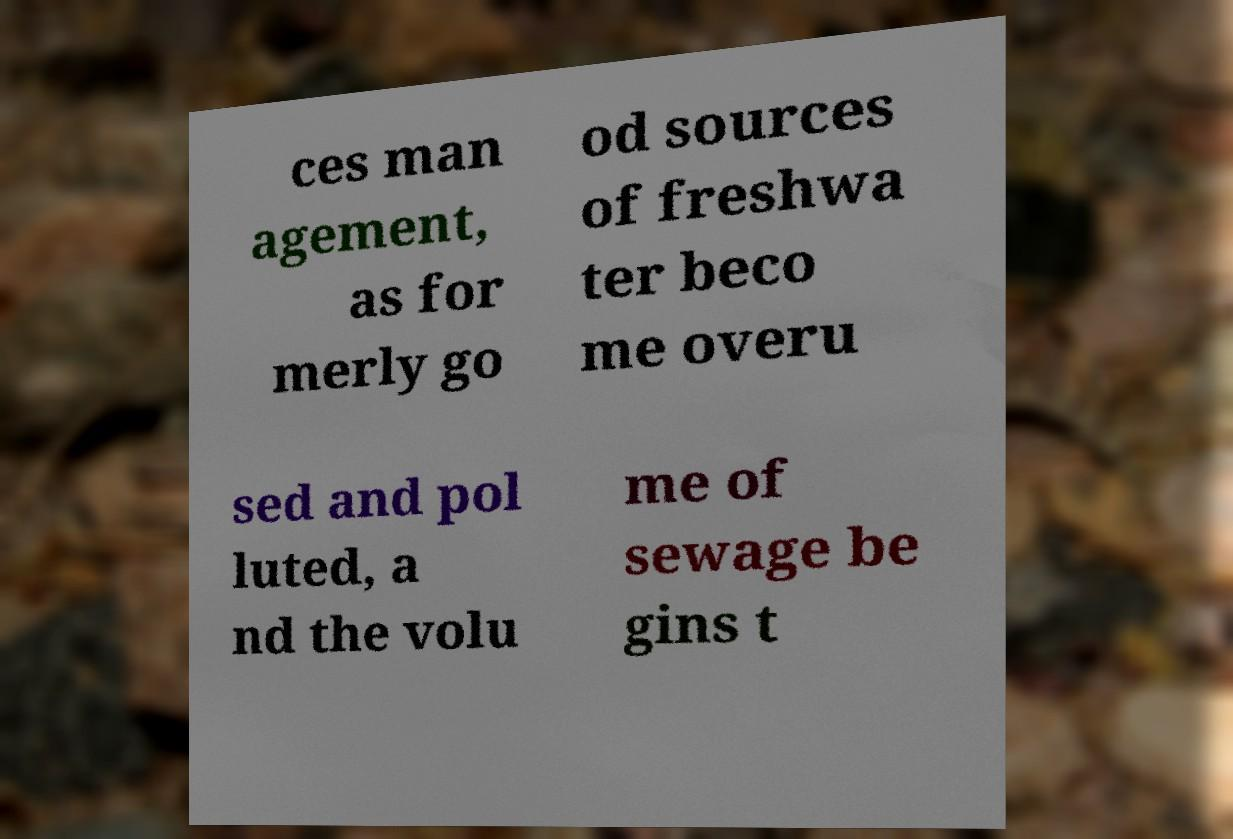Can you read and provide the text displayed in the image?This photo seems to have some interesting text. Can you extract and type it out for me? ces man agement, as for merly go od sources of freshwa ter beco me overu sed and pol luted, a nd the volu me of sewage be gins t 